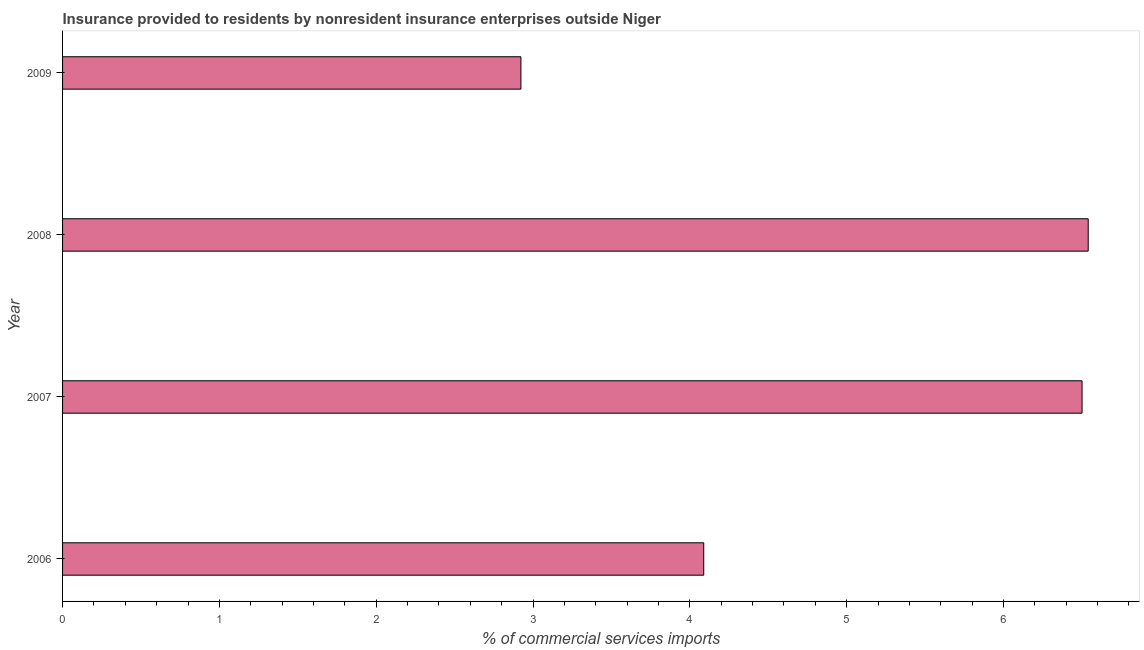Does the graph contain any zero values?
Offer a terse response. No. Does the graph contain grids?
Keep it short and to the point. No. What is the title of the graph?
Keep it short and to the point. Insurance provided to residents by nonresident insurance enterprises outside Niger. What is the label or title of the X-axis?
Provide a short and direct response. % of commercial services imports. What is the insurance provided by non-residents in 2006?
Your response must be concise. 4.09. Across all years, what is the maximum insurance provided by non-residents?
Ensure brevity in your answer.  6.54. Across all years, what is the minimum insurance provided by non-residents?
Your answer should be compact. 2.92. What is the sum of the insurance provided by non-residents?
Your response must be concise. 20.05. What is the difference between the insurance provided by non-residents in 2007 and 2008?
Ensure brevity in your answer.  -0.04. What is the average insurance provided by non-residents per year?
Provide a short and direct response. 5.01. What is the median insurance provided by non-residents?
Ensure brevity in your answer.  5.29. In how many years, is the insurance provided by non-residents greater than 1.6 %?
Your response must be concise. 4. What is the ratio of the insurance provided by non-residents in 2006 to that in 2007?
Give a very brief answer. 0.63. Is the difference between the insurance provided by non-residents in 2008 and 2009 greater than the difference between any two years?
Provide a short and direct response. Yes. What is the difference between the highest and the second highest insurance provided by non-residents?
Provide a succinct answer. 0.04. Is the sum of the insurance provided by non-residents in 2006 and 2008 greater than the maximum insurance provided by non-residents across all years?
Your answer should be very brief. Yes. What is the difference between the highest and the lowest insurance provided by non-residents?
Your answer should be compact. 3.62. In how many years, is the insurance provided by non-residents greater than the average insurance provided by non-residents taken over all years?
Provide a succinct answer. 2. How many bars are there?
Ensure brevity in your answer.  4. Are all the bars in the graph horizontal?
Offer a terse response. Yes. Are the values on the major ticks of X-axis written in scientific E-notation?
Offer a terse response. No. What is the % of commercial services imports in 2006?
Offer a very short reply. 4.09. What is the % of commercial services imports in 2007?
Give a very brief answer. 6.5. What is the % of commercial services imports of 2008?
Provide a succinct answer. 6.54. What is the % of commercial services imports of 2009?
Make the answer very short. 2.92. What is the difference between the % of commercial services imports in 2006 and 2007?
Your response must be concise. -2.41. What is the difference between the % of commercial services imports in 2006 and 2008?
Your answer should be very brief. -2.45. What is the difference between the % of commercial services imports in 2006 and 2009?
Provide a short and direct response. 1.17. What is the difference between the % of commercial services imports in 2007 and 2008?
Keep it short and to the point. -0.04. What is the difference between the % of commercial services imports in 2007 and 2009?
Offer a terse response. 3.58. What is the difference between the % of commercial services imports in 2008 and 2009?
Ensure brevity in your answer.  3.62. What is the ratio of the % of commercial services imports in 2006 to that in 2007?
Your response must be concise. 0.63. What is the ratio of the % of commercial services imports in 2006 to that in 2008?
Give a very brief answer. 0.62. What is the ratio of the % of commercial services imports in 2006 to that in 2009?
Your answer should be compact. 1.4. What is the ratio of the % of commercial services imports in 2007 to that in 2008?
Offer a very short reply. 0.99. What is the ratio of the % of commercial services imports in 2007 to that in 2009?
Your response must be concise. 2.22. What is the ratio of the % of commercial services imports in 2008 to that in 2009?
Offer a very short reply. 2.24. 